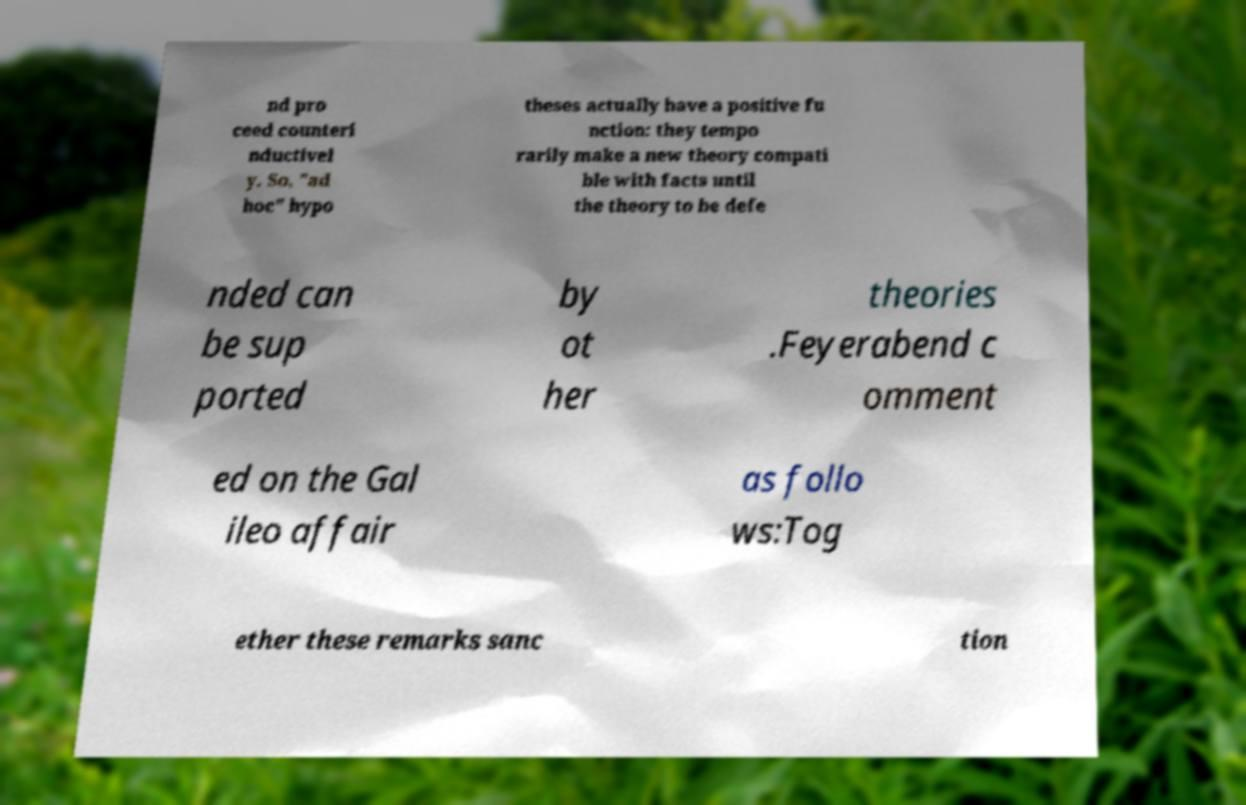I need the written content from this picture converted into text. Can you do that? nd pro ceed counteri nductivel y. So, "ad hoc" hypo theses actually have a positive fu nction: they tempo rarily make a new theory compati ble with facts until the theory to be defe nded can be sup ported by ot her theories .Feyerabend c omment ed on the Gal ileo affair as follo ws:Tog ether these remarks sanc tion 